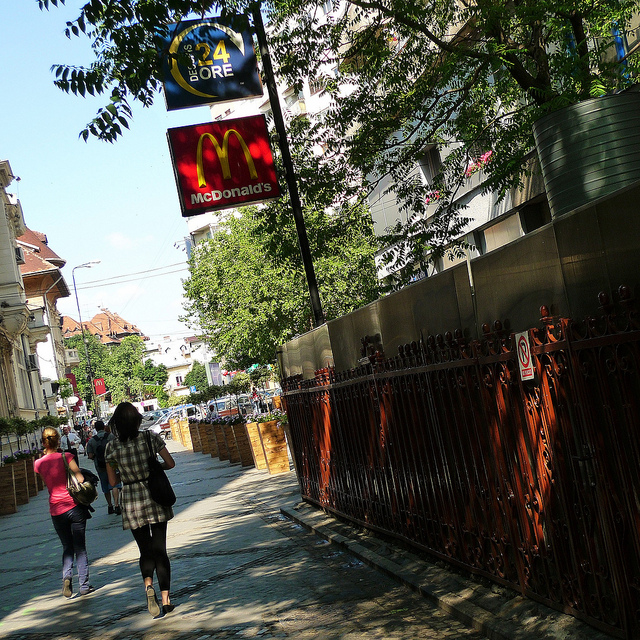<image>The black and white sign next to the plant suggests that this is part of what kind of display? I don't know  what kind of display this is part of. The answers suggest a variety of possibilities including a wildlife display, an art exhibition, a restaurant or food advertisement, a business display, an urban scene, a no-parking area, or a historical site. The black and white sign next to the plant suggests that this is part of what kind of display? I am not sure what kind of display this is. It can be wildlife, art, restaurant, food, business, urban, advertisement or historical. 